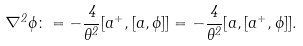<formula> <loc_0><loc_0><loc_500><loc_500>\nabla ^ { 2 } \phi \colon = - \frac { 4 } { \theta ^ { 2 } } [ a ^ { + } , [ a , \phi ] ] = - \frac { 4 } { \theta ^ { 2 } } [ a , [ a ^ { + } , \phi ] ] .</formula> 